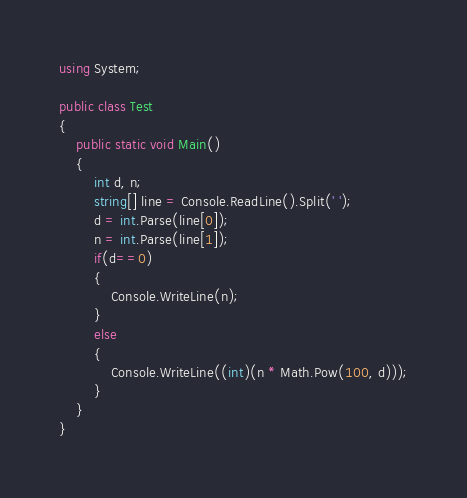<code> <loc_0><loc_0><loc_500><loc_500><_C#_>using System;

public class Test
{
	public static void Main()
	{
		int d, n;
		string[] line = Console.ReadLine().Split(' ');
		d = int.Parse(line[0]);
		n = int.Parse(line[1]);
		if(d==0)
		{
			Console.WriteLine(n);
		}
		else
		{
			Console.WriteLine((int)(n * Math.Pow(100, d)));
		}
	}
}
</code> 